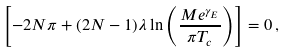<formula> <loc_0><loc_0><loc_500><loc_500>\left [ - 2 N \pi + ( 2 N - 1 ) \lambda \ln \left ( \frac { M e ^ { \gamma _ { E } } } { \pi T _ { c } } \right ) \right ] = 0 \, ,</formula> 